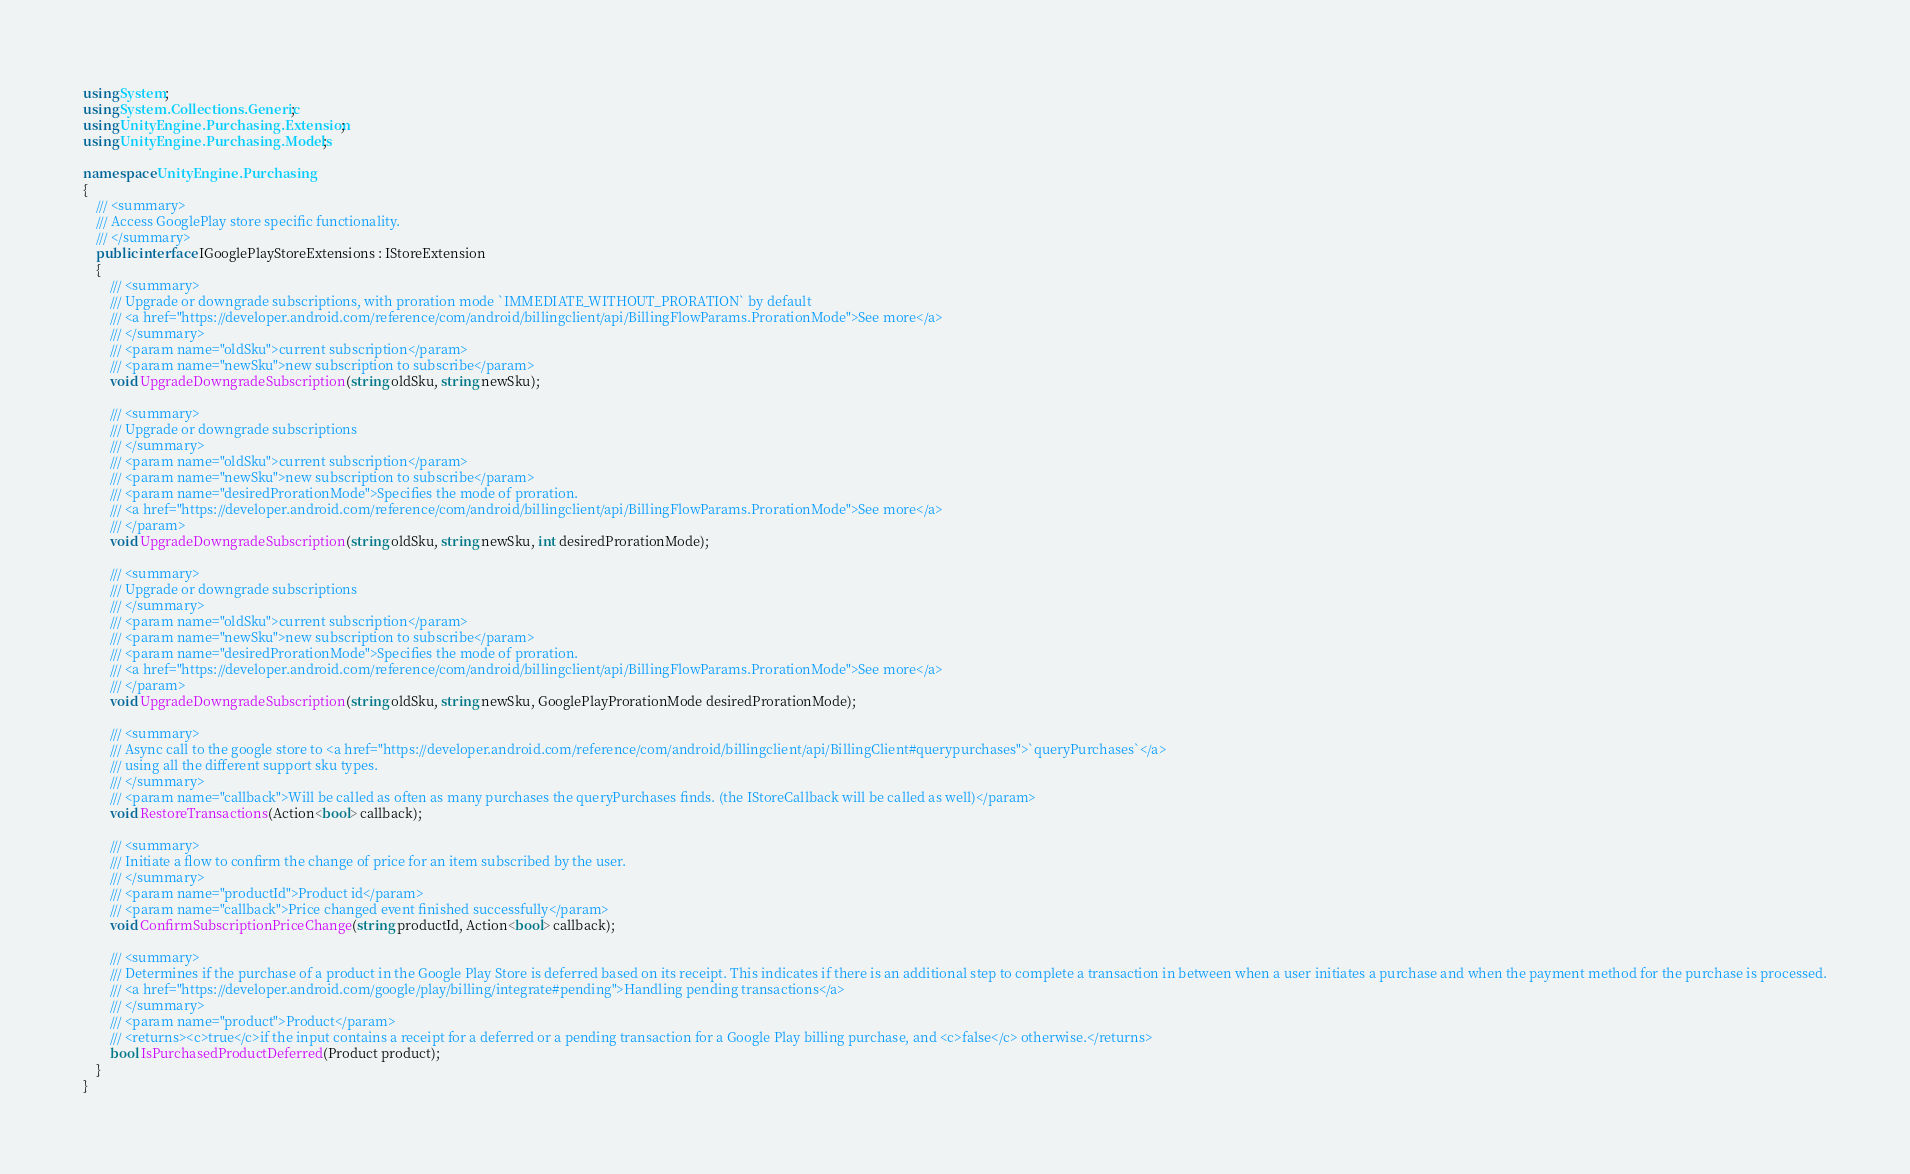Convert code to text. <code><loc_0><loc_0><loc_500><loc_500><_C#_>using System;
using System.Collections.Generic;
using UnityEngine.Purchasing.Extension;
using UnityEngine.Purchasing.Models;

namespace UnityEngine.Purchasing
{
	/// <summary>
	/// Access GooglePlay store specific functionality.
	/// </summary>
	public interface IGooglePlayStoreExtensions : IStoreExtension
    {
        /// <summary>
        /// Upgrade or downgrade subscriptions, with proration mode `IMMEDIATE_WITHOUT_PRORATION` by default
        /// <a href="https://developer.android.com/reference/com/android/billingclient/api/BillingFlowParams.ProrationMode">See more</a>
        /// </summary>
        /// <param name="oldSku">current subscription</param>
        /// <param name="newSku">new subscription to subscribe</param>
        void UpgradeDowngradeSubscription(string oldSku, string newSku);

        /// <summary>
        /// Upgrade or downgrade subscriptions
        /// </summary>
        /// <param name="oldSku">current subscription</param>
        /// <param name="newSku">new subscription to subscribe</param>
        /// <param name="desiredProrationMode">Specifies the mode of proration.
        /// <a href="https://developer.android.com/reference/com/android/billingclient/api/BillingFlowParams.ProrationMode">See more</a>
        /// </param>
        void UpgradeDowngradeSubscription(string oldSku, string newSku, int desiredProrationMode);

        /// <summary>
        /// Upgrade or downgrade subscriptions
        /// </summary>
        /// <param name="oldSku">current subscription</param>
        /// <param name="newSku">new subscription to subscribe</param>
        /// <param name="desiredProrationMode">Specifies the mode of proration.
        /// <a href="https://developer.android.com/reference/com/android/billingclient/api/BillingFlowParams.ProrationMode">See more</a>
        /// </param>
        void UpgradeDowngradeSubscription(string oldSku, string newSku, GooglePlayProrationMode desiredProrationMode);

        /// <summary>
        /// Async call to the google store to <a href="https://developer.android.com/reference/com/android/billingclient/api/BillingClient#querypurchases">`queryPurchases`</a>
        /// using all the different support sku types.
        /// </summary>
        /// <param name="callback">Will be called as often as many purchases the queryPurchases finds. (the IStoreCallback will be called as well)</param>
        void RestoreTransactions(Action<bool> callback);

        /// <summary>
        /// Initiate a flow to confirm the change of price for an item subscribed by the user.
        /// </summary>
        /// <param name="productId">Product id</param>
        /// <param name="callback">Price changed event finished successfully</param>
        void ConfirmSubscriptionPriceChange(string productId, Action<bool> callback);

        /// <summary>
        /// Determines if the purchase of a product in the Google Play Store is deferred based on its receipt. This indicates if there is an additional step to complete a transaction in between when a user initiates a purchase and when the payment method for the purchase is processed.
        /// <a href="https://developer.android.com/google/play/billing/integrate#pending">Handling pending transactions</a>
        /// </summary>
        /// <param name="product">Product</param>
        /// <returns><c>true</c>if the input contains a receipt for a deferred or a pending transaction for a Google Play billing purchase, and <c>false</c> otherwise.</returns>
        bool IsPurchasedProductDeferred(Product product);
    }
}
</code> 